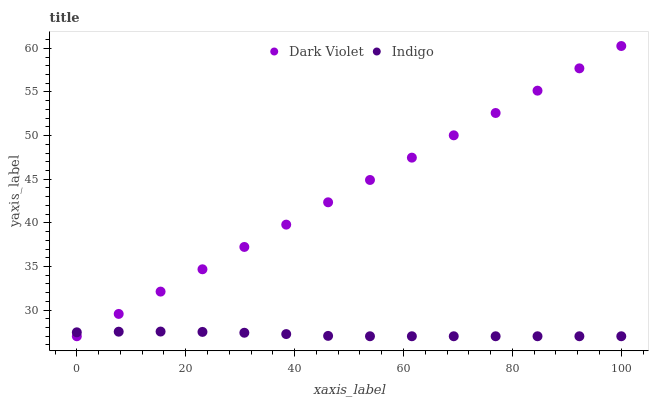Does Indigo have the minimum area under the curve?
Answer yes or no. Yes. Does Dark Violet have the maximum area under the curve?
Answer yes or no. Yes. Does Dark Violet have the minimum area under the curve?
Answer yes or no. No. Is Dark Violet the smoothest?
Answer yes or no. Yes. Is Indigo the roughest?
Answer yes or no. Yes. Is Dark Violet the roughest?
Answer yes or no. No. Does Indigo have the lowest value?
Answer yes or no. Yes. Does Dark Violet have the highest value?
Answer yes or no. Yes. Does Indigo intersect Dark Violet?
Answer yes or no. Yes. Is Indigo less than Dark Violet?
Answer yes or no. No. Is Indigo greater than Dark Violet?
Answer yes or no. No. 